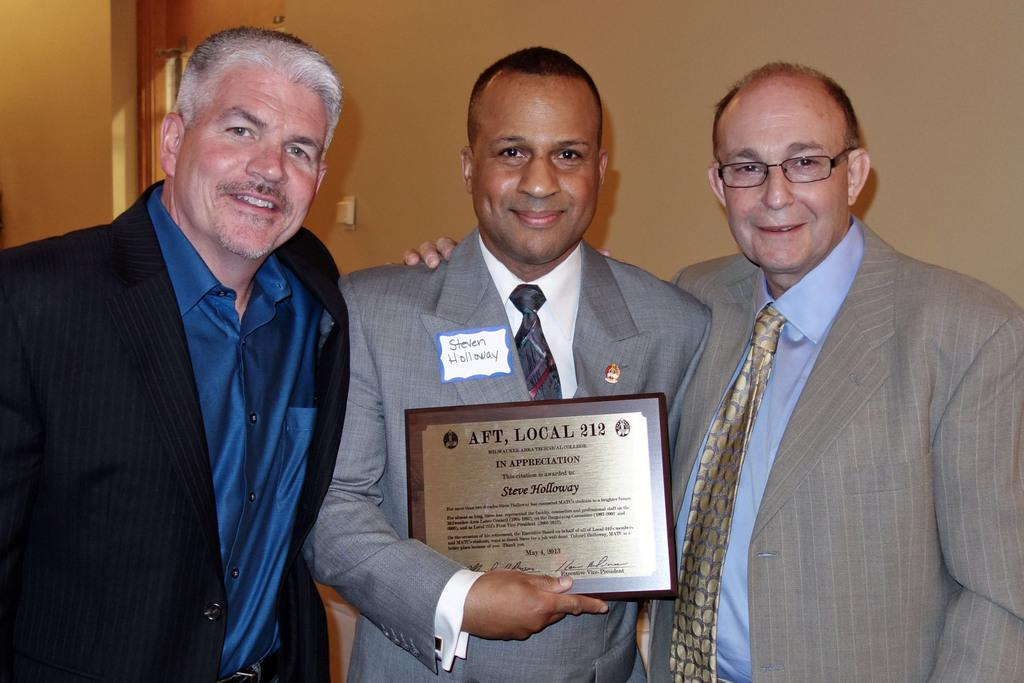How many people are in the image? There are three persons in the image. What are the persons wearing? The persons are wearing blazers. What are the persons doing in the image? The persons are standing. What is the person in the middle holding? The person in the middle is holding an object. What can be seen in the background of the image? There is a wall and a door in the background of the image. What type of language can be heard being spoken by the seashore in the image? There is no seashore present in the image, and therefore no language can be heard being spoken by the seashore. What type of rod is being used by the person in the image? There is no rod present in the image; the person in the middle is holding an object, but it is not specified as a rod. 